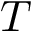Convert formula to latex. <formula><loc_0><loc_0><loc_500><loc_500>T</formula> 